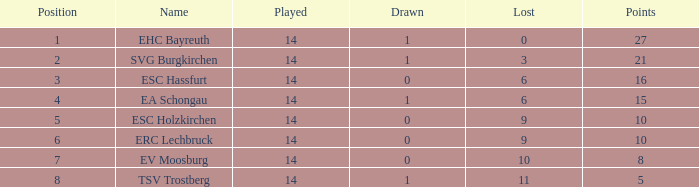What's the loss when there were greater than 16 points and had a stalemate less than 1? None. 